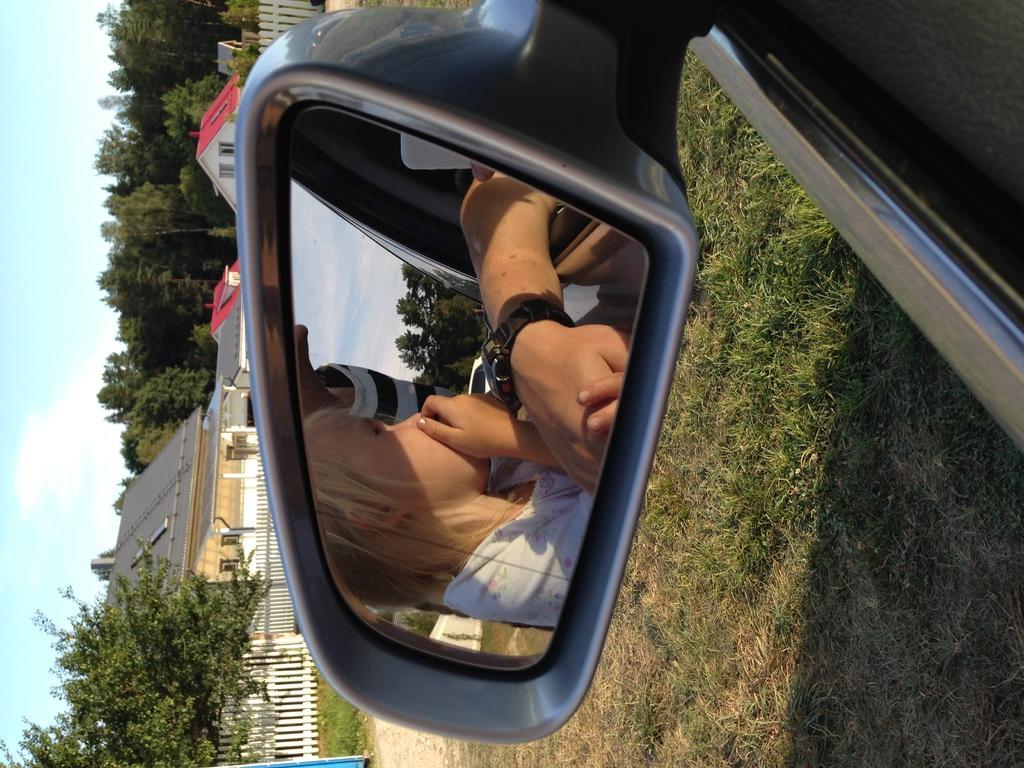In one or two sentences, can you explain what this image depicts? In this image I can see the side mirror of the vehicle. In the mirror I can see two people with different color dresses, tree and the sky. Outside of the vehicle I can see few houses and railing to the side. There are many trees and the sky in the back. 